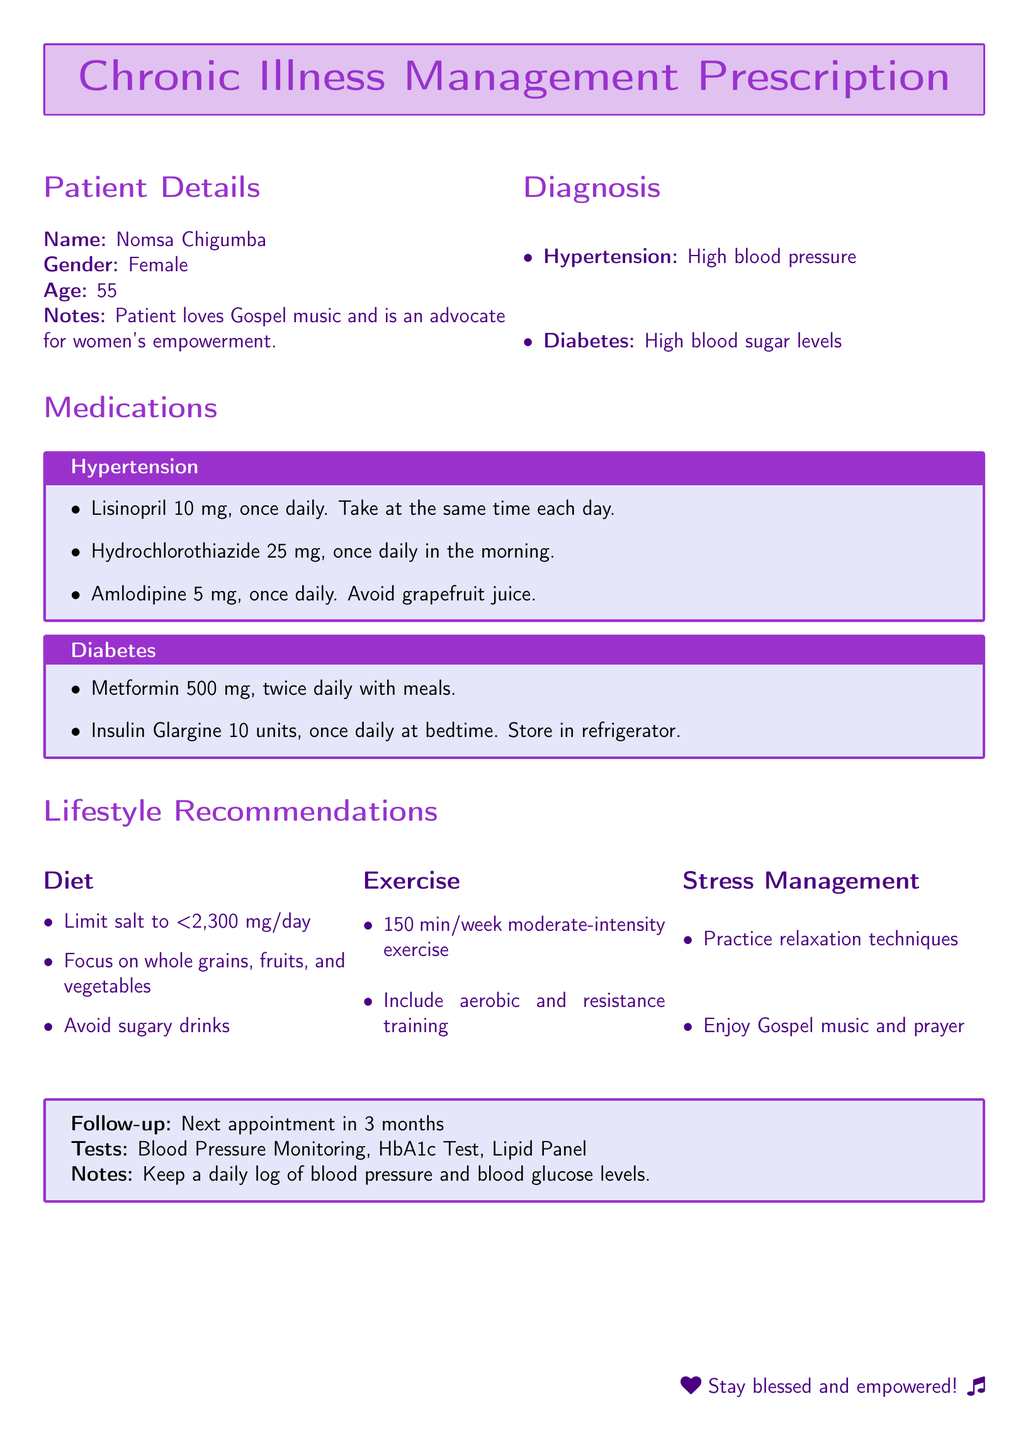What is the patient's name? The patient's name is listed in the patient details section of the document.
Answer: Nomsa Chigumba What medication is prescribed for hypertension? The section titled "Medications" provides the names of medications for hypertension.
Answer: Lisinopril What is the dosage of Metformin? The diabetes medications section specifies the dosage for Metformin.
Answer: 500 mg How often should Insulin Glargine be taken? The document outlines the frequency of taking Insulin Glargine under diabetes management.
Answer: Once daily What dietary recommendation is made regarding salt intake? The lifestyle recommendations include dietary guidelines about salt consumption.
Answer: Limit salt to <2,300 mg/day How many minutes of exercise are recommended per week? The exercise section provides a specific amount of moderate-intensity exercise time per week.
Answer: 150 min/week What relaxation technique is suggested for stress management? The stress management section suggests practices that can aid in relaxation.
Answer: Practice relaxation techniques When is the next follow-up appointment scheduled? The follow-up notes provide the timing for the next appointment.
Answer: In 3 months What is the purpose of keeping a daily log? The notes section explains the reason for maintaining a daily log of specific health metrics.
Answer: Blood pressure and blood glucose levels 